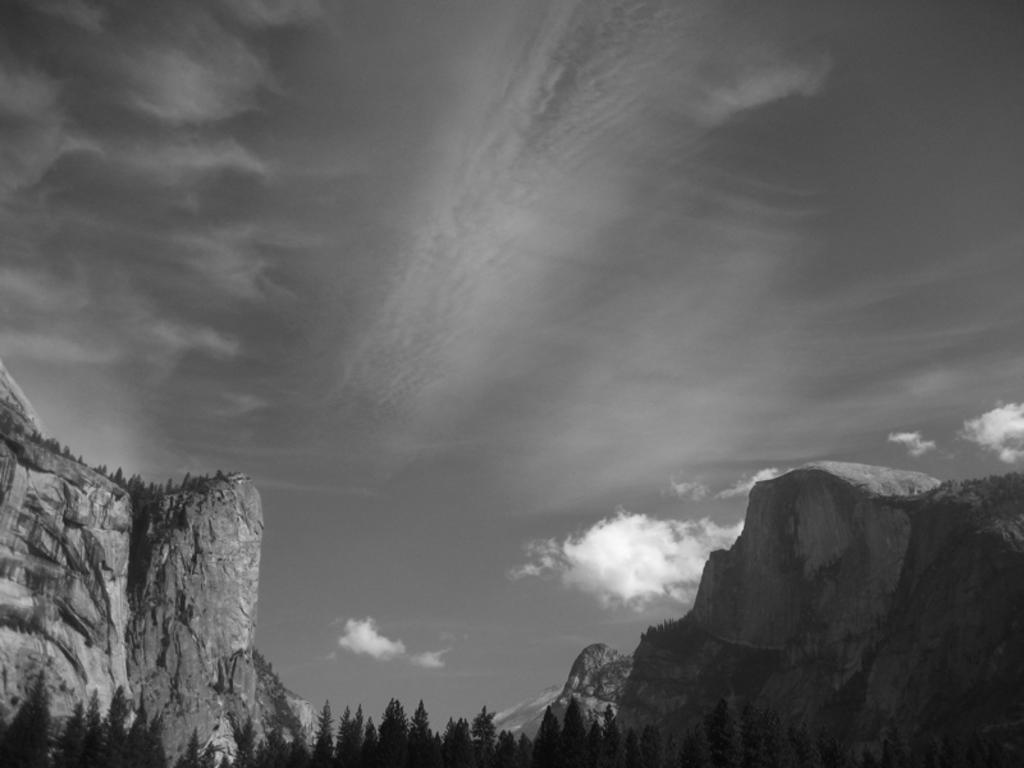Can you describe this image briefly? In this image I can see number of trees and in the background I can see clouds and the sky. I can also see this image is black and white in colour. 